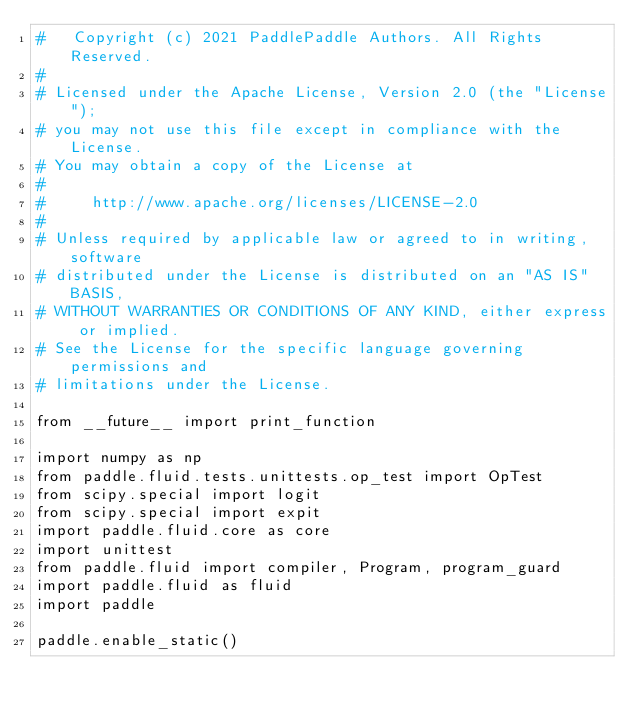Convert code to text. <code><loc_0><loc_0><loc_500><loc_500><_Python_>#   Copyright (c) 2021 PaddlePaddle Authors. All Rights Reserved.
#
# Licensed under the Apache License, Version 2.0 (the "License");
# you may not use this file except in compliance with the License.
# You may obtain a copy of the License at
#
#     http://www.apache.org/licenses/LICENSE-2.0
#
# Unless required by applicable law or agreed to in writing, software
# distributed under the License is distributed on an "AS IS" BASIS,
# WITHOUT WARRANTIES OR CONDITIONS OF ANY KIND, either express or implied.
# See the License for the specific language governing permissions and
# limitations under the License.

from __future__ import print_function

import numpy as np
from paddle.fluid.tests.unittests.op_test import OpTest
from scipy.special import logit
from scipy.special import expit
import paddle.fluid.core as core
import unittest
from paddle.fluid import compiler, Program, program_guard
import paddle.fluid as fluid
import paddle

paddle.enable_static()

</code> 